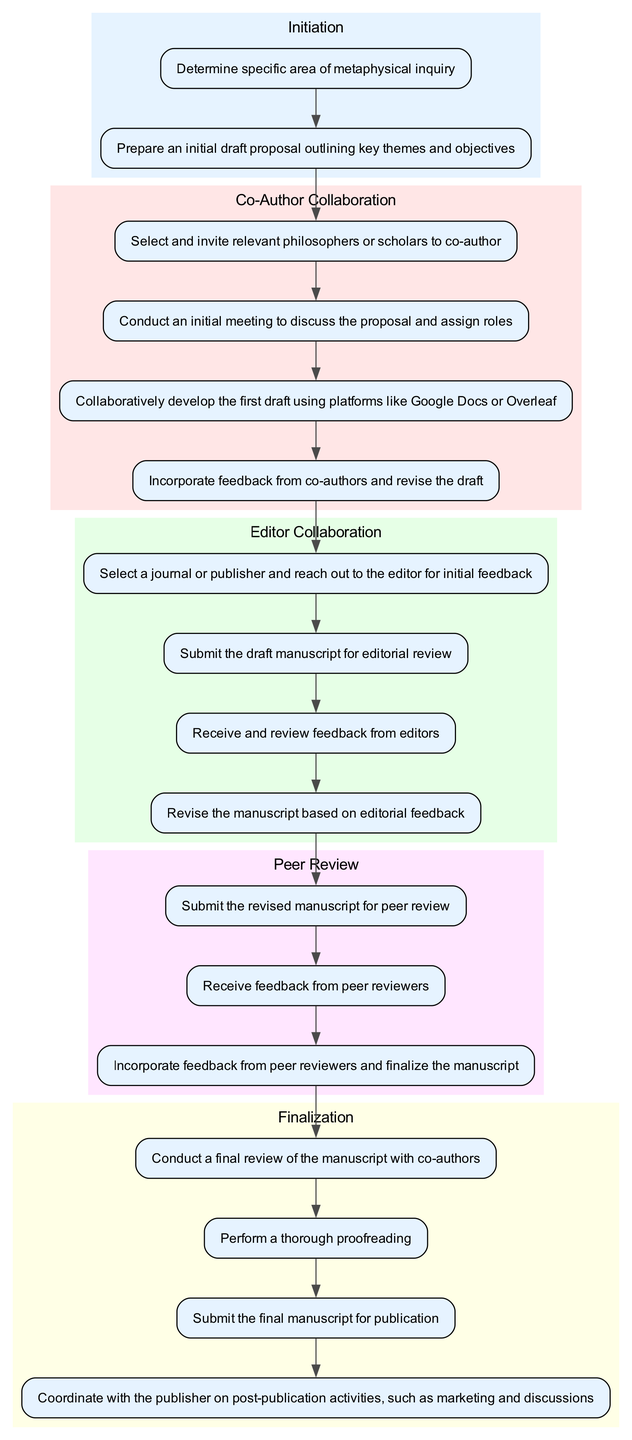What is the first step in the collaboration workflow? The first step, as indicated in the diagram, is "Determine specific area of metaphysical inquiry." This is the initial action that leads to the proposal draft.
Answer: Determine specific area of metaphysical inquiry How many nodes are present in the "Co-Author Collaboration" subgraph? In the "Co-Author Collaboration" subgraph, there are four nodes: "Select and invite relevant philosophers or scholars to co-author," "Conduct an initial meeting to discuss the proposal and assign roles," "Collaboratively develop the first draft using platforms like Google Docs or Overleaf," and "Incorporate feedback from co-authors and revise the draft." Therefore, the total count is four.
Answer: Four What follows after "Incorporate feedback from co-authors and revise the draft"? The process flows to the next step, which is "Select a journal or publisher and reach out to the editor for initial feedback." This indicates the continuation of collaboration towards the editor.
Answer: Select a journal or publisher and reach out to the editor for initial feedback Which phase includes "Submit the final manuscript for publication"? This action is located in the "Finalization" phase of the workflow. "Submit the final manuscript for publication" concludes the overall publishing procedures after all revisions have been incorporated.
Answer: Finalization How many edges connect the "editorial feedback" node? The "editorial feedback" node has one outgoing edge that connects to the "revise the manuscript based on editorial feedback" node. This indicates the linear relationship and next step following the feedback reception.
Answer: One What is the last action in the entire workflow? The last action in the workflow is "Coordinate with the publisher on post-publication activities, such as marketing and discussions." This wraps up the entire collaboration process.
Answer: Coordinate with the publisher on post-publication activities, such as marketing and discussions Which node is connected to “Receive feedback from peer reviewers”? The node "Incorporate feedback from peer reviewers and finalize the manuscript" is directly connected, indicating it is the subsequent step in the workflow after receiving peer review feedback.
Answer: Incorporate feedback from peer reviewers and finalize the manuscript What is the relationship between "Prepare an initial draft proposal outlining key themes and objectives" and "Select and invite relevant philosophers or scholars to co-author"? The first node leads into the second; after preparing the initial draft proposal, the next step is to select and invite co-authors for collaboration, establishing a progression in the workflow.
Answer: It follows from one to the other 